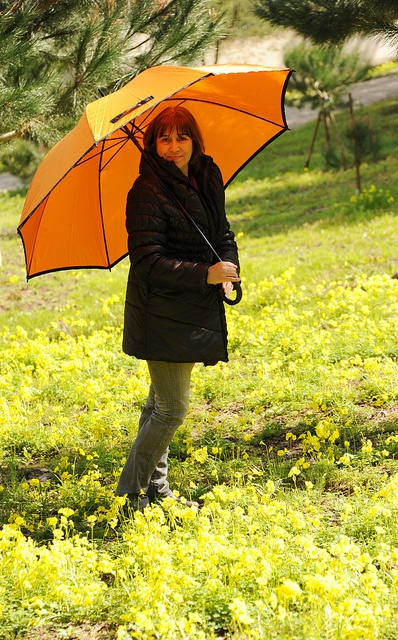Describe the objects in this image and their specific colors. I can see people in black, darkgreen, maroon, and red tones and umbrella in black, red, orange, and gold tones in this image. 